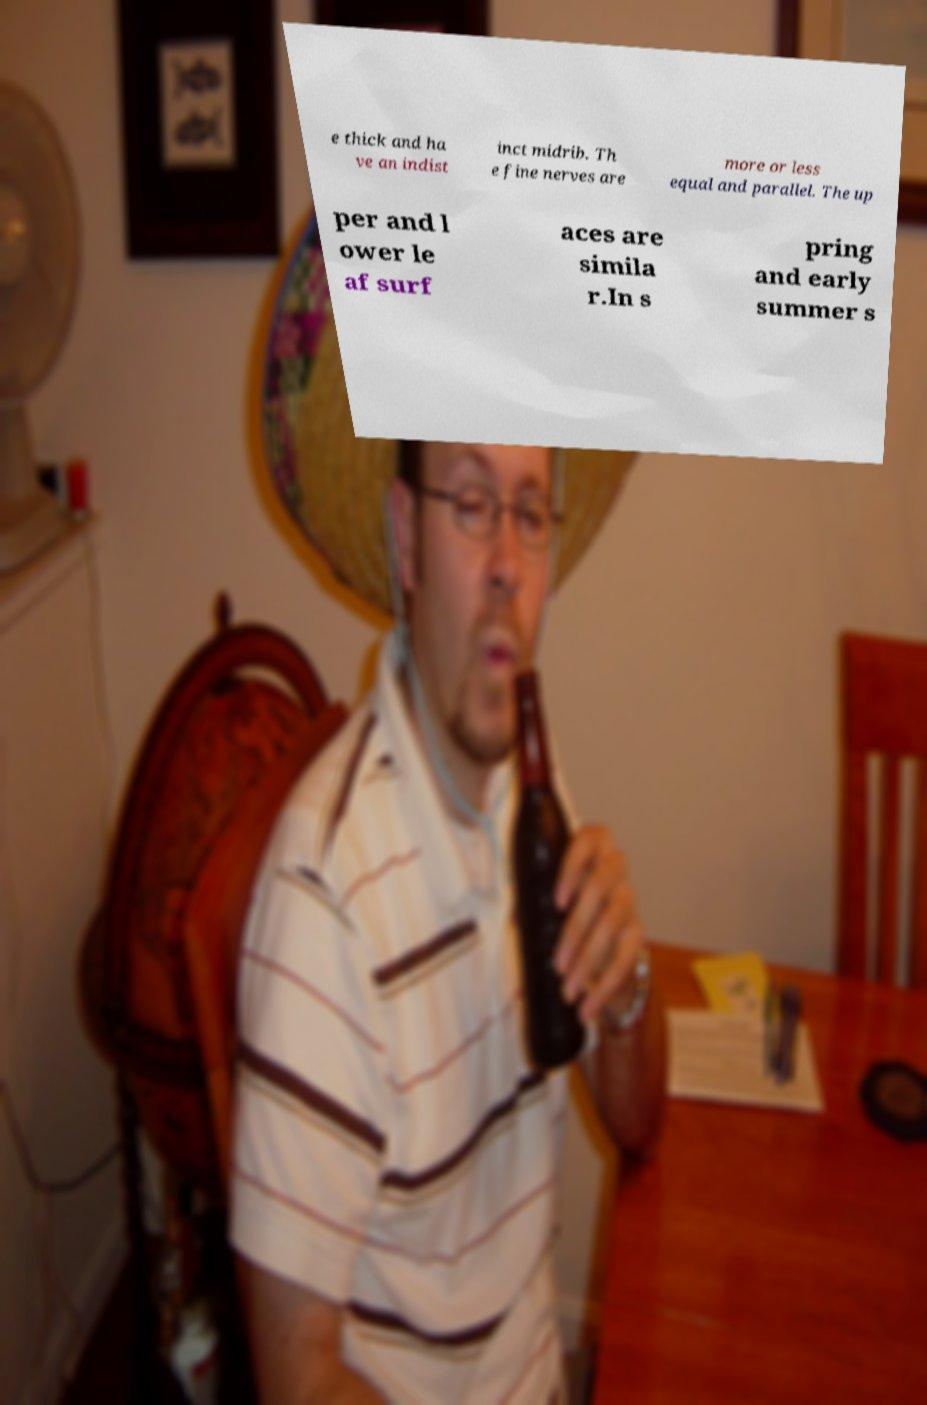For documentation purposes, I need the text within this image transcribed. Could you provide that? e thick and ha ve an indist inct midrib. Th e fine nerves are more or less equal and parallel. The up per and l ower le af surf aces are simila r.In s pring and early summer s 